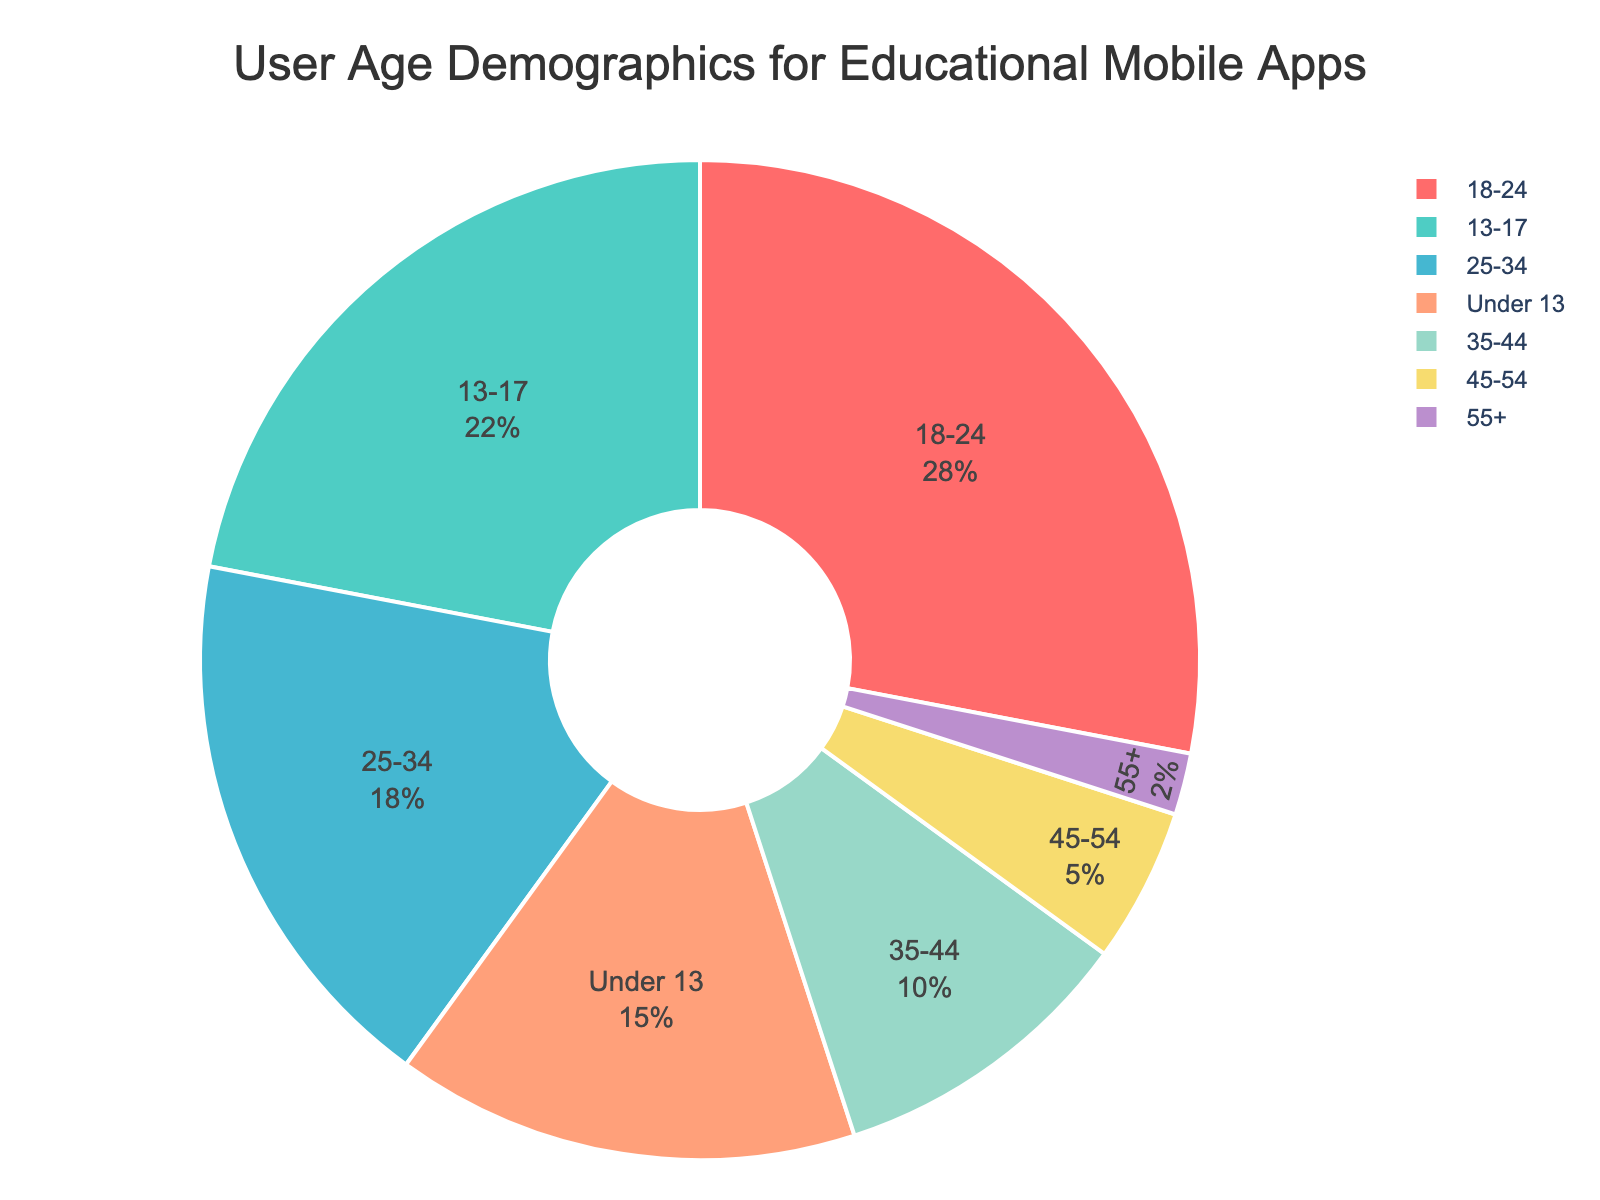What age group holds the largest share of user demographics? By examining the pie chart, we can see that the "18-24" age group has the largest segment. This visual information indicates that this group has the highest percentage among all age groups.
Answer: 18-24 What is the percentage difference between the "Under 13" and "25-34" age groups? The "Under 13" age group is 15%, and the "25-34" age group is 18%. The percentage difference is calculated as 18% - 15%.
Answer: 3% Which two age groups combined make up less than 10% of the user demographics? The age groups "45-54" and "55+" have percentages of 5% and 2%, respectively. Summing these values gives us 5% + 2%, which totals 7%.
Answer: 45-54 and 55+ Which age group has approximately half the percentage of the "18-24" age group? The "18-24" age group has 28%. Analyzing the pie chart, the "Under 13" group, which has 15%, is slightly over half but very close.
Answer: Under 13 Is the percentage of users aged "35-44" greater or less than the total percentage of users aged "Under 13" and "55+" combined? The "35-44" age group has 10%. Adding the percentages of "Under 13" (15%) and "55+" (2%) gives 17%. Comparing 10% with 17%, 10% is less.
Answer: less Which age group holds the smallest share of user demographics, and what color represents it? The smallest share belongs to the "55+" age group, which is represented by the light purple color. This is the smallest segment in the pie chart, visually evident as well.
Answer: 55+, light purple How many age groups have less than a 20% share in user demographics, and can you list them? The pie chart shows that the age groups "55+", "45-54", "35-44", "Under 13", and "25-34" have percentages less than 20. Counting these gives a total of five groups.
Answer: five, 55+, 45-54, 35-44, Under 13, 25-34 What is the combined percentage of users aged between "13-24"? Summing the percentages of the "13-17" (22%) and "18-24" (28%) age groups gives 22% + 28%.
Answer: 50% Which age group segment is represented by the green color, and what is their percentage share? In the pie chart, the green segment represents the "13-17" age group. The chart indicates that their share is 22%.
Answer: 13-17, 22% 